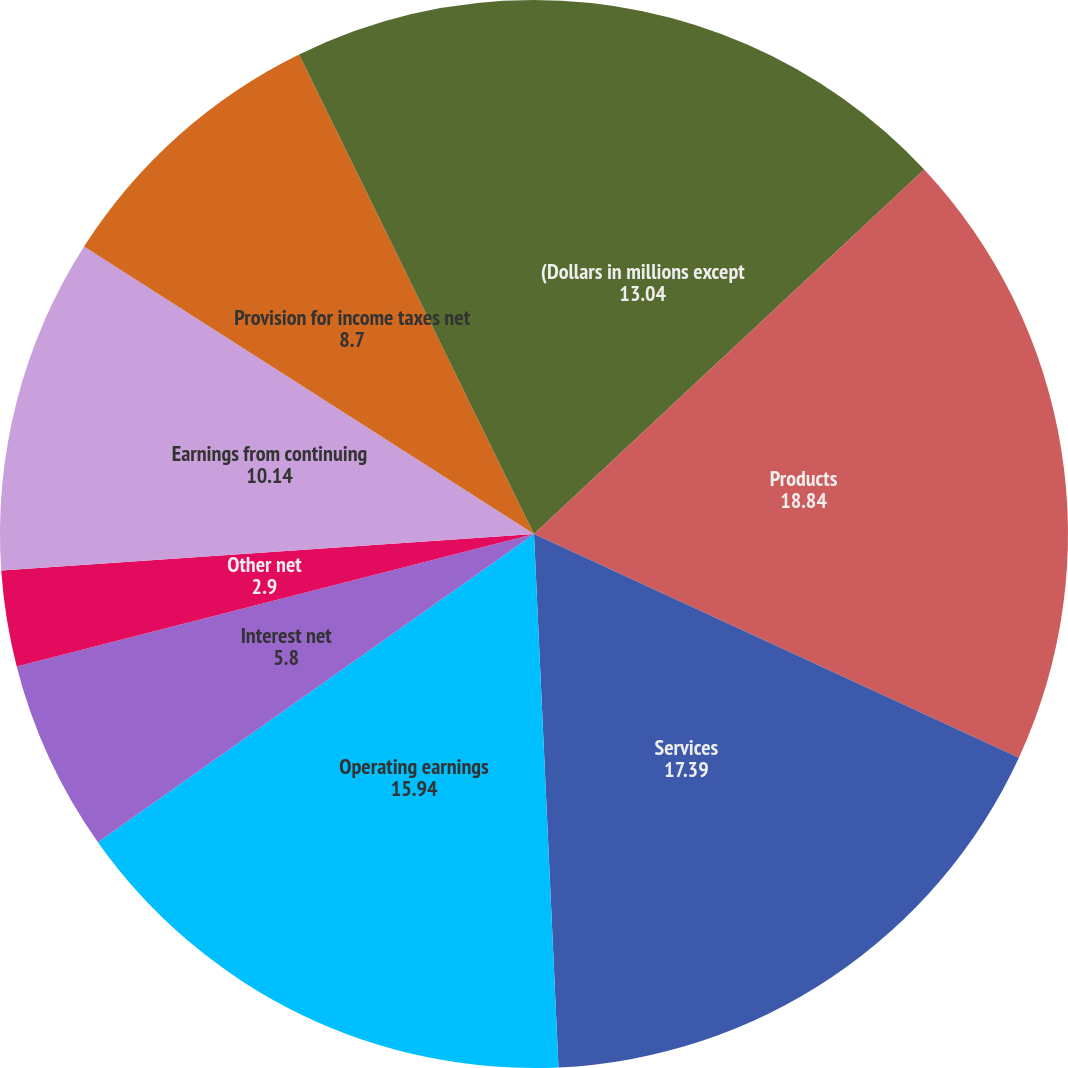<chart> <loc_0><loc_0><loc_500><loc_500><pie_chart><fcel>(Dollars in millions except<fcel>Products<fcel>Services<fcel>Operating earnings<fcel>Interest net<fcel>Other net<fcel>Earnings from continuing<fcel>Provision for income taxes net<fcel>Discontinued operations net of<nl><fcel>13.04%<fcel>18.84%<fcel>17.39%<fcel>15.94%<fcel>5.8%<fcel>2.9%<fcel>10.14%<fcel>8.7%<fcel>7.25%<nl></chart> 